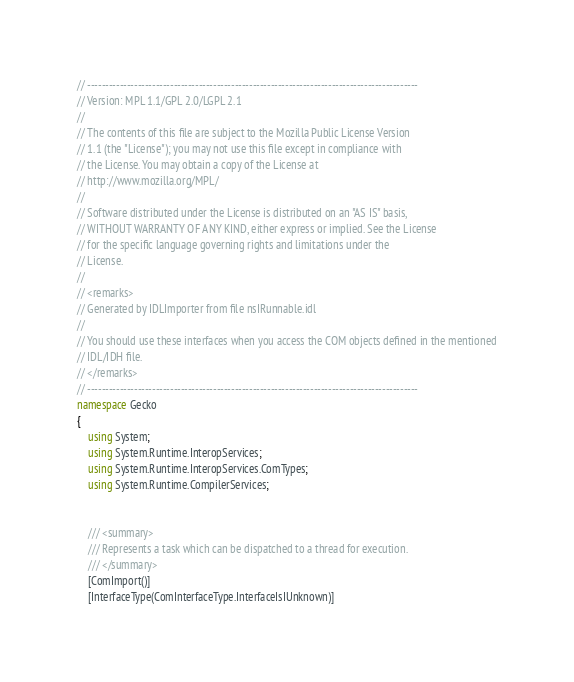<code> <loc_0><loc_0><loc_500><loc_500><_C#_>// --------------------------------------------------------------------------------------------
// Version: MPL 1.1/GPL 2.0/LGPL 2.1
// 
// The contents of this file are subject to the Mozilla Public License Version
// 1.1 (the "License"); you may not use this file except in compliance with
// the License. You may obtain a copy of the License at
// http://www.mozilla.org/MPL/
// 
// Software distributed under the License is distributed on an "AS IS" basis,
// WITHOUT WARRANTY OF ANY KIND, either express or implied. See the License
// for the specific language governing rights and limitations under the
// License.
// 
// <remarks>
// Generated by IDLImporter from file nsIRunnable.idl
// 
// You should use these interfaces when you access the COM objects defined in the mentioned
// IDL/IDH file.
// </remarks>
// --------------------------------------------------------------------------------------------
namespace Gecko
{
	using System;
	using System.Runtime.InteropServices;
	using System.Runtime.InteropServices.ComTypes;
	using System.Runtime.CompilerServices;
	
	
	/// <summary>
    /// Represents a task which can be dispatched to a thread for execution.
    /// </summary>
	[ComImport()]
	[InterfaceType(ComInterfaceType.InterfaceIsIUnknown)]</code> 